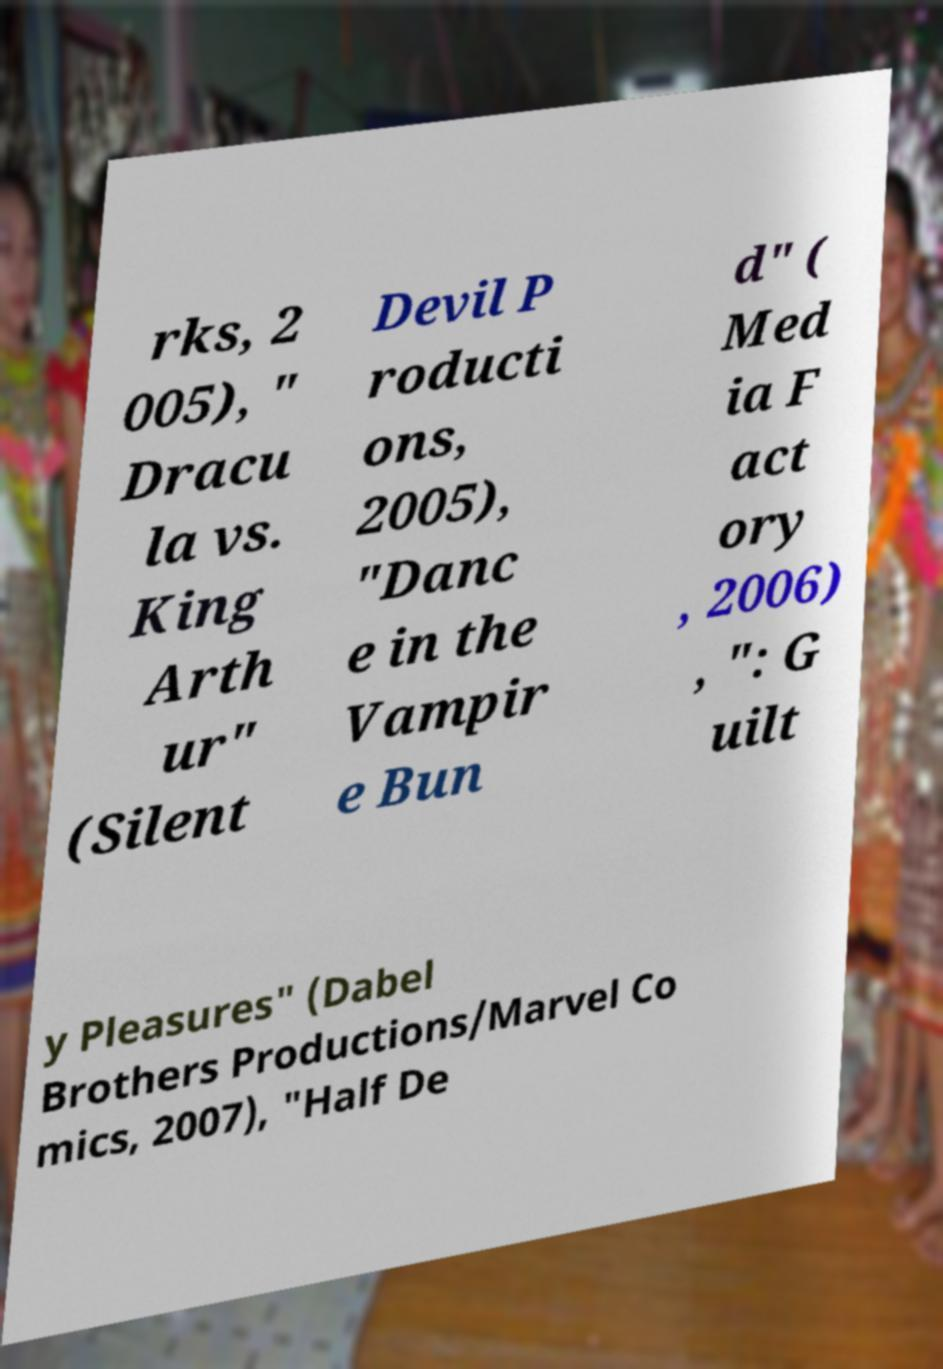Please read and relay the text visible in this image. What does it say? rks, 2 005), " Dracu la vs. King Arth ur" (Silent Devil P roducti ons, 2005), "Danc e in the Vampir e Bun d" ( Med ia F act ory , 2006) , ": G uilt y Pleasures" (Dabel Brothers Productions/Marvel Co mics, 2007), "Half De 